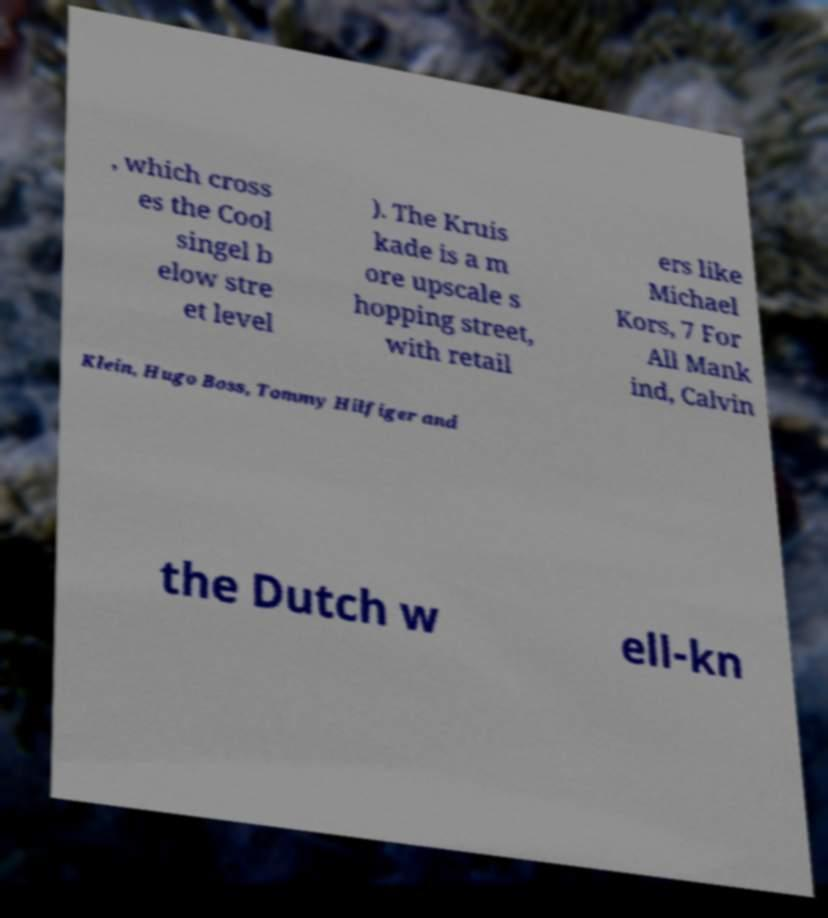Can you read and provide the text displayed in the image?This photo seems to have some interesting text. Can you extract and type it out for me? , which cross es the Cool singel b elow stre et level ). The Kruis kade is a m ore upscale s hopping street, with retail ers like Michael Kors, 7 For All Mank ind, Calvin Klein, Hugo Boss, Tommy Hilfiger and the Dutch w ell-kn 